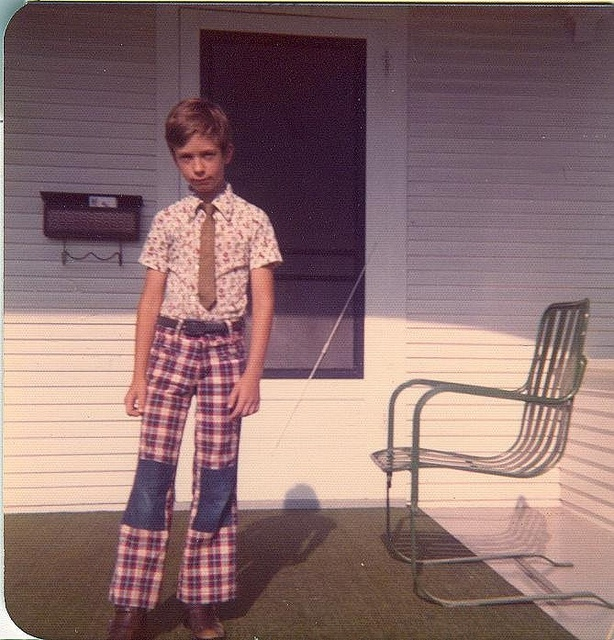Describe the objects in this image and their specific colors. I can see people in lightblue, brown, lightpink, and purple tones, chair in lightblue, gray, tan, and darkgray tones, and tie in lightblue, brown, salmon, and maroon tones in this image. 